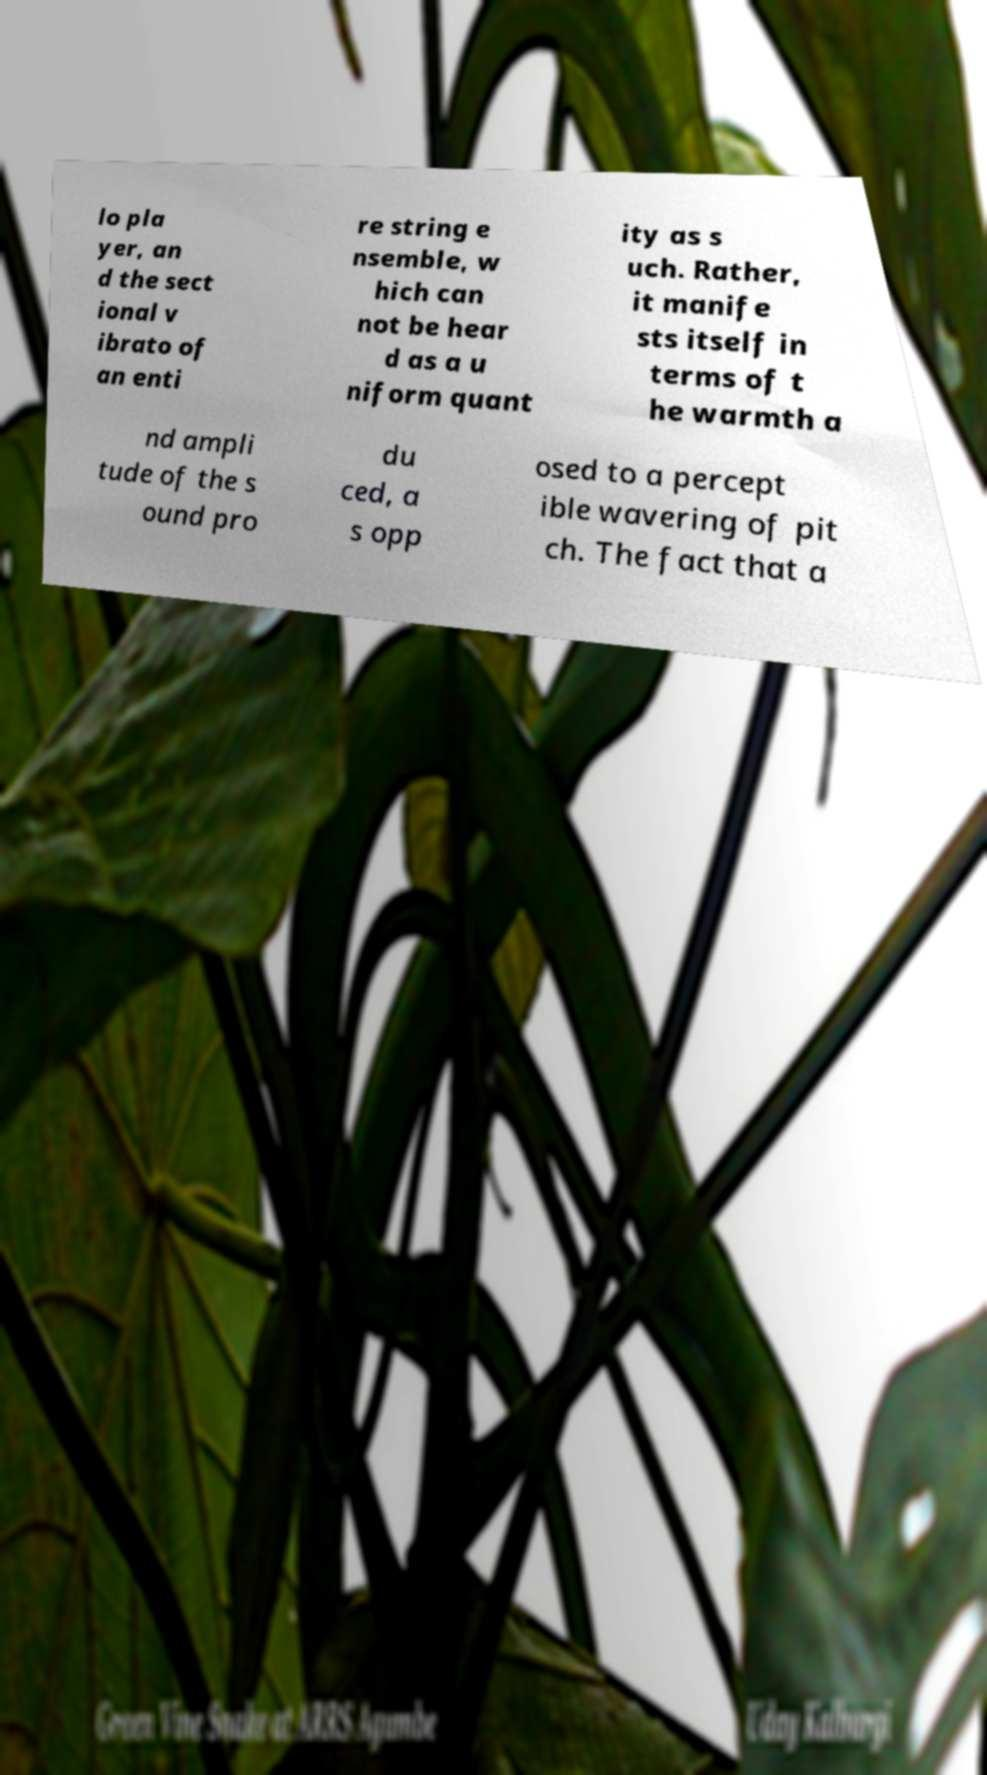What messages or text are displayed in this image? I need them in a readable, typed format. lo pla yer, an d the sect ional v ibrato of an enti re string e nsemble, w hich can not be hear d as a u niform quant ity as s uch. Rather, it manife sts itself in terms of t he warmth a nd ampli tude of the s ound pro du ced, a s opp osed to a percept ible wavering of pit ch. The fact that a 